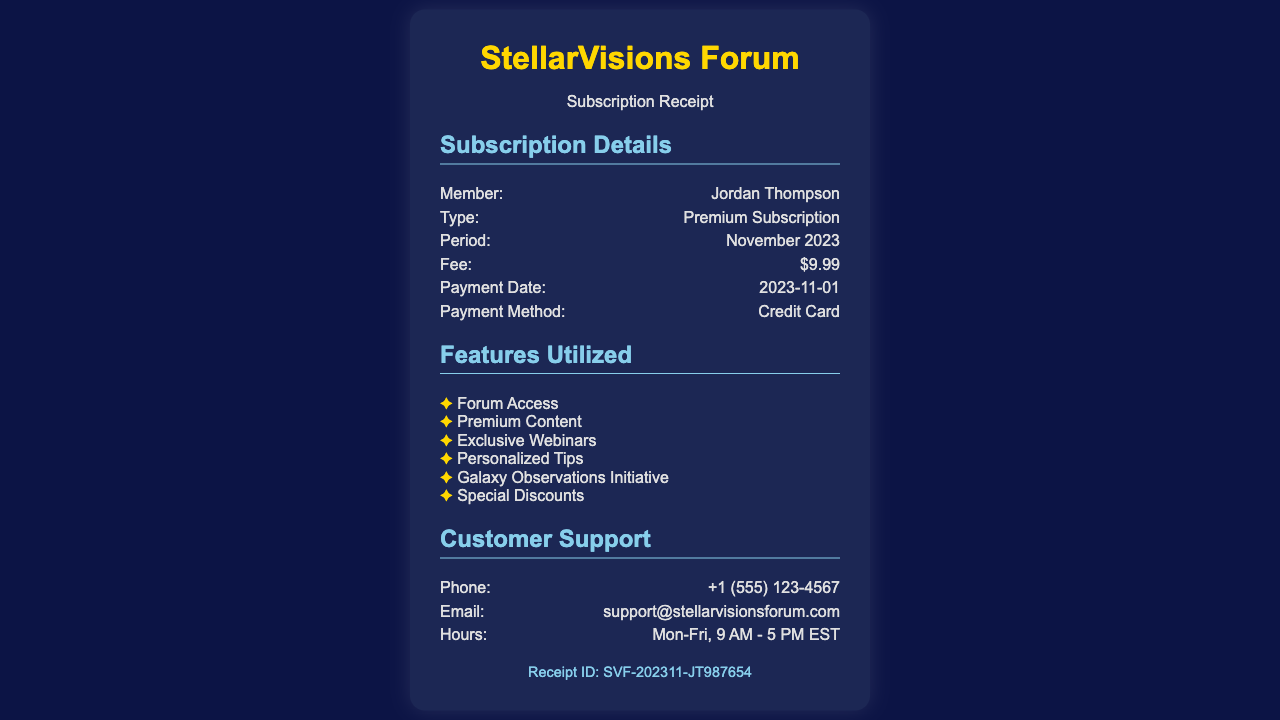What is the member's name? The document specifies the name of the member who made the subscription.
Answer: Jordan Thompson What is the subscription type? The document states the type of subscription the member has purchased.
Answer: Premium Subscription What is the subscription fee for November 2023? The fee amount for the subscription period is explicitly mentioned in the document.
Answer: $9.99 When was the payment date? The document provides the specific date when the payment was processed.
Answer: 2023-11-01 What payment method was used? The receipt indicates the method through which the subscription was paid.
Answer: Credit Card What feature allows personalized assistance? The document lists specific features, one of which pertains to personalized support.
Answer: Personalized Tips How many features are listed in the document? The total features utilized in the subscription are enumerated in the features section.
Answer: Six What is the receipt ID? The document contains a unique identifier for this transaction.
Answer: SVF-202311-JT987654 What are the customer support hours? The hours for customer support are explicitly mentioned in the support section.
Answer: Mon-Fri, 9 AM - 5 PM EST 